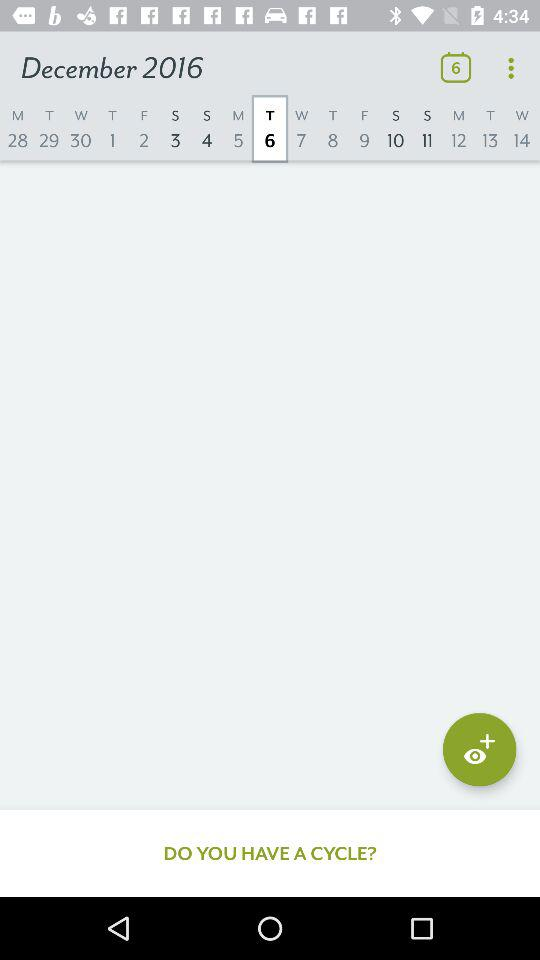What is the year? The year is 2016. 